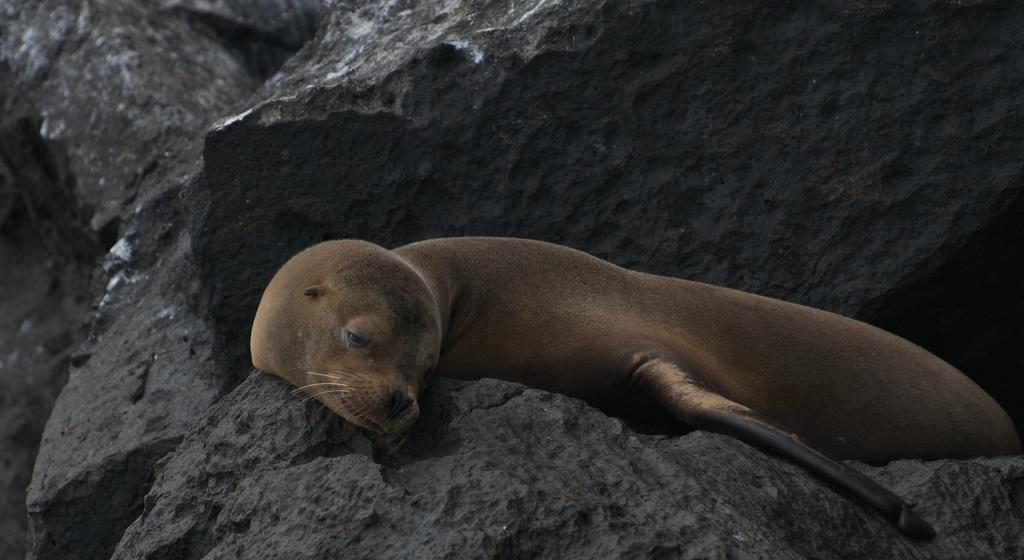What type of creature is in the image? There is an animal in the image. Where is the animal located? The animal is on a rock. What can be seen in the background of the image? There are more rocks visible in the background of the image. What type of nerve can be seen in the image? There is no nerve present in the image; it features an animal on a rock with more rocks visible in the background. 